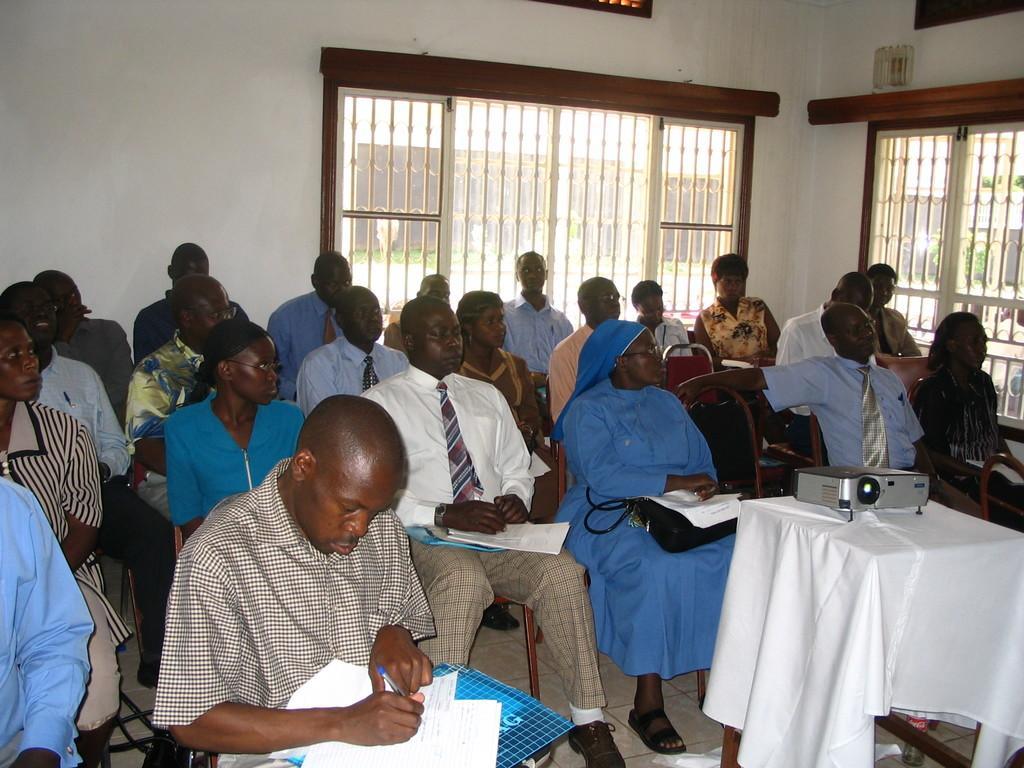How would you summarize this image in a sentence or two? A group of people are sitting on the chairs and looking at the right side. There is a window behind them. 